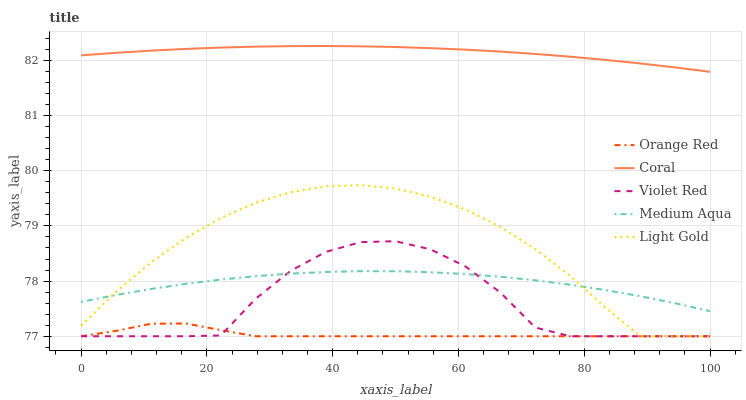Does Orange Red have the minimum area under the curve?
Answer yes or no. Yes. Does Coral have the maximum area under the curve?
Answer yes or no. Yes. Does Light Gold have the minimum area under the curve?
Answer yes or no. No. Does Light Gold have the maximum area under the curve?
Answer yes or no. No. Is Coral the smoothest?
Answer yes or no. Yes. Is Violet Red the roughest?
Answer yes or no. Yes. Is Light Gold the smoothest?
Answer yes or no. No. Is Light Gold the roughest?
Answer yes or no. No. Does Violet Red have the lowest value?
Answer yes or no. Yes. Does Coral have the lowest value?
Answer yes or no. No. Does Coral have the highest value?
Answer yes or no. Yes. Does Light Gold have the highest value?
Answer yes or no. No. Is Violet Red less than Coral?
Answer yes or no. Yes. Is Coral greater than Orange Red?
Answer yes or no. Yes. Does Orange Red intersect Light Gold?
Answer yes or no. Yes. Is Orange Red less than Light Gold?
Answer yes or no. No. Is Orange Red greater than Light Gold?
Answer yes or no. No. Does Violet Red intersect Coral?
Answer yes or no. No. 